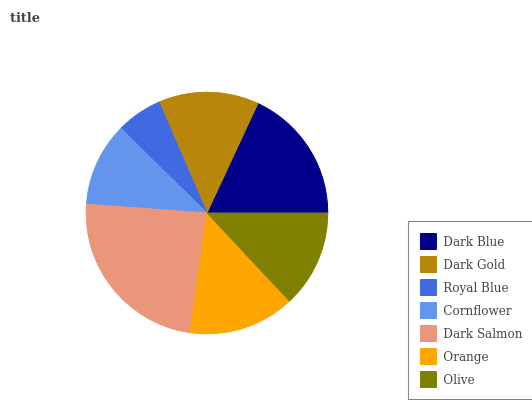Is Royal Blue the minimum?
Answer yes or no. Yes. Is Dark Salmon the maximum?
Answer yes or no. Yes. Is Dark Gold the minimum?
Answer yes or no. No. Is Dark Gold the maximum?
Answer yes or no. No. Is Dark Blue greater than Dark Gold?
Answer yes or no. Yes. Is Dark Gold less than Dark Blue?
Answer yes or no. Yes. Is Dark Gold greater than Dark Blue?
Answer yes or no. No. Is Dark Blue less than Dark Gold?
Answer yes or no. No. Is Dark Gold the high median?
Answer yes or no. Yes. Is Dark Gold the low median?
Answer yes or no. Yes. Is Orange the high median?
Answer yes or no. No. Is Dark Blue the low median?
Answer yes or no. No. 